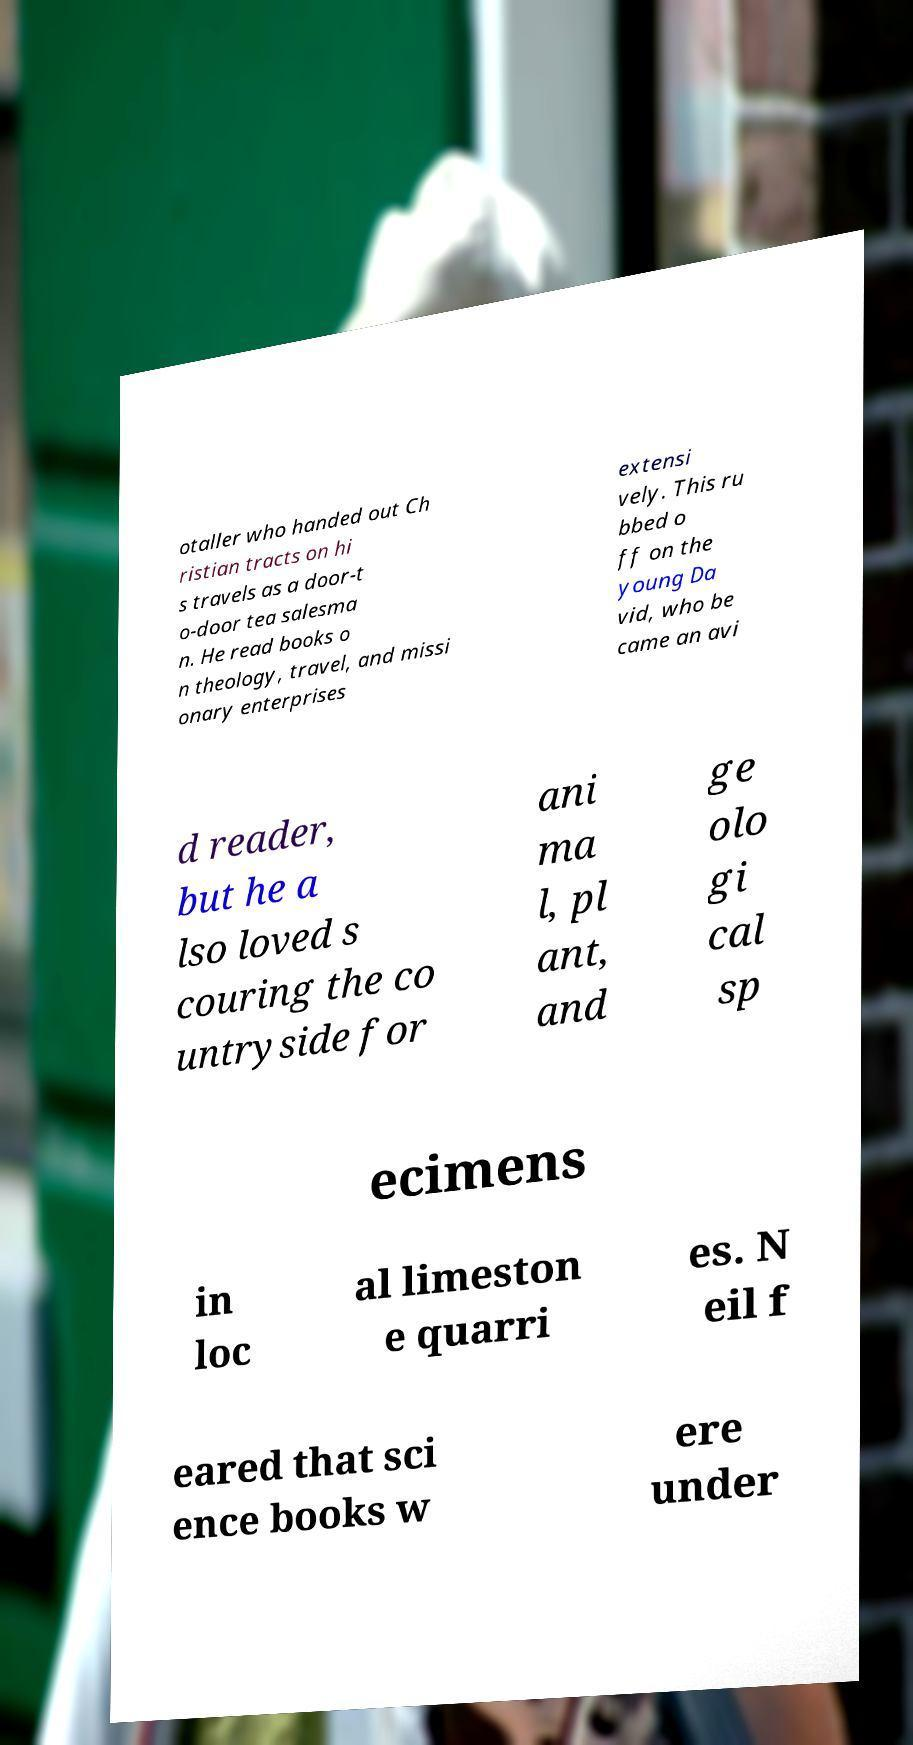There's text embedded in this image that I need extracted. Can you transcribe it verbatim? otaller who handed out Ch ristian tracts on hi s travels as a door-t o-door tea salesma n. He read books o n theology, travel, and missi onary enterprises extensi vely. This ru bbed o ff on the young Da vid, who be came an avi d reader, but he a lso loved s couring the co untryside for ani ma l, pl ant, and ge olo gi cal sp ecimens in loc al limeston e quarri es. N eil f eared that sci ence books w ere under 